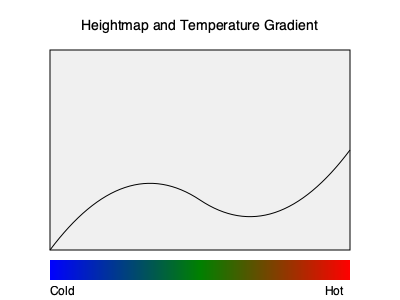Given a heightmap represented by the curve in the image and a temperature gradient shown at the bottom, implement a custom biome generation algorithm that creates unique biomes based on both elevation and temperature. How would you determine the biome type for a given (x, y, z) coordinate in the Minecraft world? To implement a custom biome generation algorithm based on the provided heightmap and temperature gradient, follow these steps:

1. Heightmap interpretation:
   - The curve in the image represents the terrain elevation.
   - Convert the heightmap to a function $h(x, z)$ that returns the y-coordinate for any given (x, z) position.

2. Temperature gradient interpretation:
   - The gradient at the bottom represents temperature variation from cold (blue) to hot (red).
   - Create a function $t(x, z)$ that returns a temperature value between 0 (coldest) and 1 (hottest) for any (x, z) coordinate.

3. Biome classification:
   - Define biome types based on combinations of elevation and temperature.
   - For example:
     - Low elevation, cold: Tundra
     - Low elevation, moderate: Plains
     - Low elevation, hot: Desert
     - Mid elevation, cold: Taiga
     - Mid elevation, moderate: Forest
     - Mid elevation, hot: Savanna
     - High elevation, cold: Snowy Mountains
     - High elevation, moderate: Mountains
     - High elevation, hot: Mesa

4. Biome determination algorithm:
   For a given (x, y, z) coordinate:
   a. Calculate the expected height: $y_{expected} = h(x, z)$
   b. Determine the elevation category:
      - If $y < y_{expected} - \delta$: Underground
      - If $y_{expected} - \delta \leq y \leq y_{expected} + \delta$: Surface
      - If $y > y_{expected} + \delta$: Air
      (where $\delta$ is a small threshold value)
   c. If the point is on the surface:
      - Get the temperature: $temp = t(x, z)$
      - Classify the elevation as low, mid, or high based on $y_{expected}$
      - Use the elevation classification and temperature to determine the biome type

5. Implementation in Minecraft:
   - Create a custom `BiomeProvider` class that extends `BiomeProvider`
   - Override the `getNoiseBiome(int x, int y, int z)` method to implement the algorithm
   - Use the algorithm to return the appropriate `Biome` object for the given coordinates

6. Integration:
   - Register the custom `BiomeProvider` in your plugin's main class
   - Apply the custom biome provider to the world generator settings

By following these steps, you can create a custom biome generation algorithm that takes into account both the heightmap and temperature gradient to produce unique and varied biomes in your Minecraft world.
Answer: Implement a custom BiomeProvider that determines biome type based on elevation (from heightmap) and temperature (from gradient) for surface-level coordinates. 